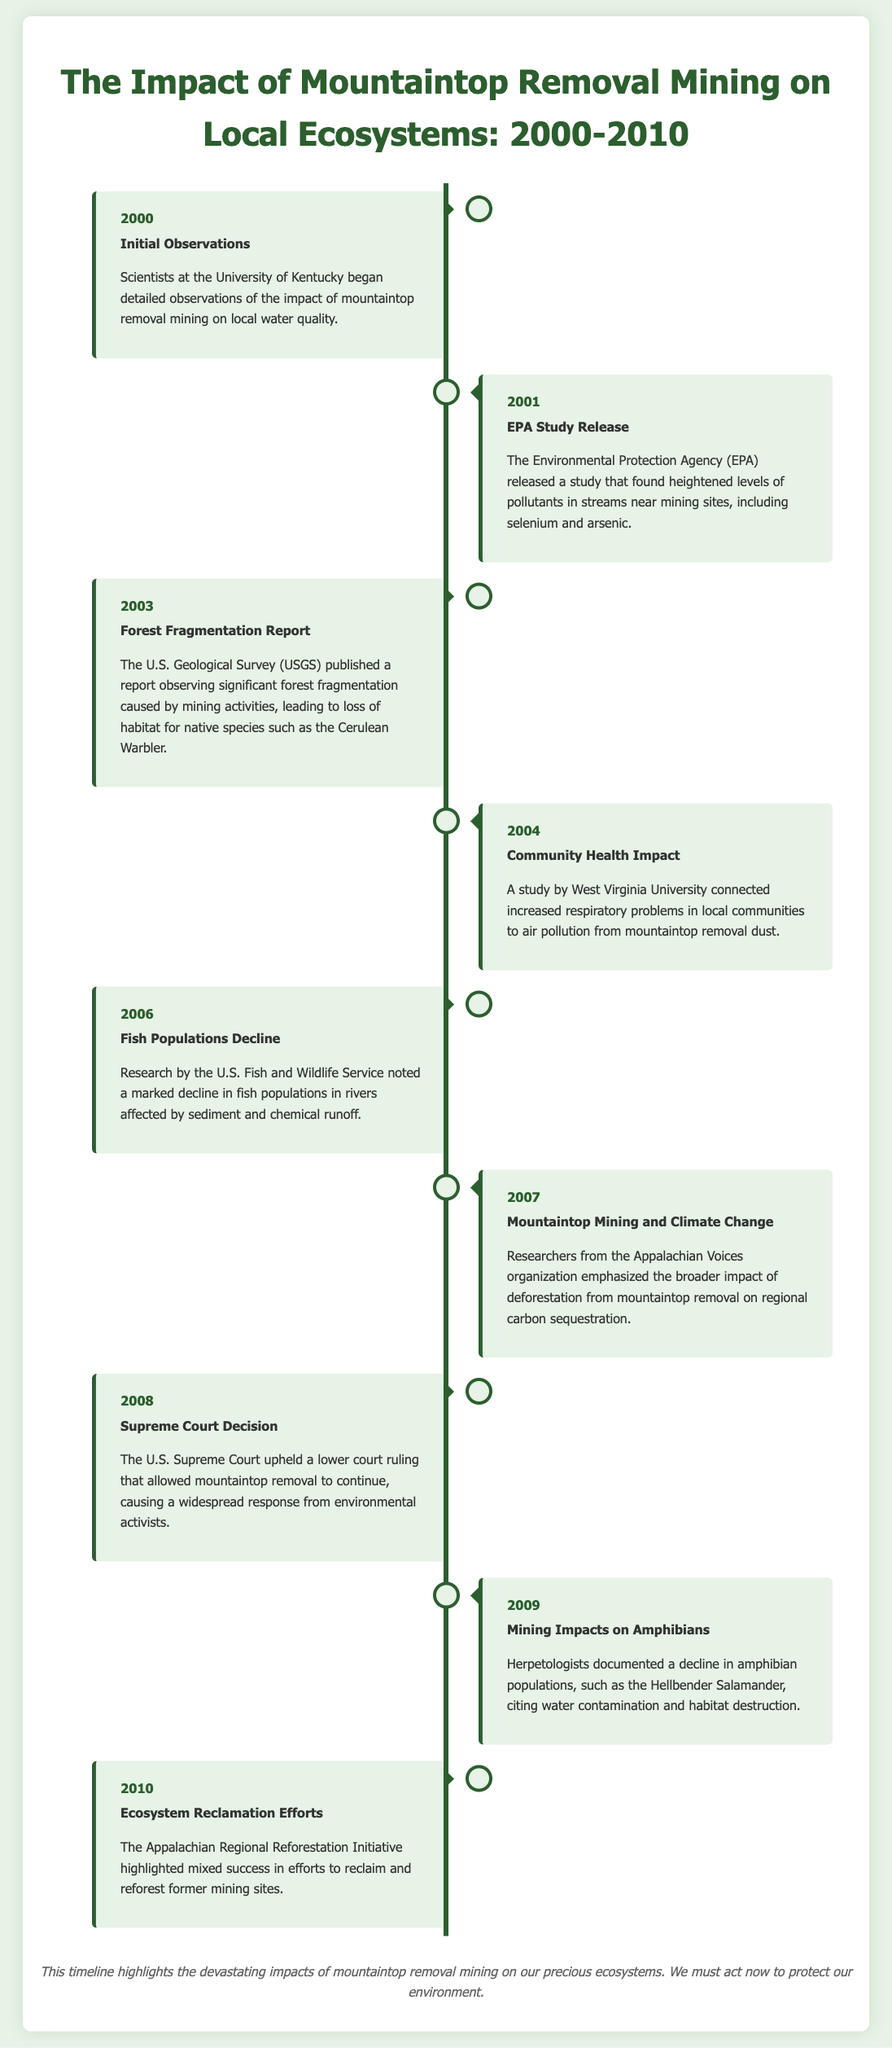What year did scientists at the University of Kentucky begin observing the impact of mountaintop removal mining? The document states that detailed observations began in 2000.
Answer: 2000 What pollutants did the EPA study find heightened levels of near mining sites? The pollutants mentioned in the EPA study are selenium and arsenic.
Answer: Selenium and arsenic Which report observed significant forest fragmentation caused by mining activities? The U.S. Geological Survey published the report on forest fragmentation.
Answer: U.S. Geological Survey What species was noted as losing habitat due to forest fragmentation in 2003? The Cerulean Warbler was specifically mentioned as losing habitat.
Answer: Cerulean Warbler What year did the U.S. Supreme Court uphold a ruling that allowed mountaintop removal to continue? The ruling was upheld in 2008.
Answer: 2008 Which amphibian's population declined due to water contamination and habitat destruction? The Hellbender Salamander was documented for this decline.
Answer: Hellbender Salamander What initiative highlighted mixed success in reforesting former mining sites by 2010? The Appalachian Regional Reforestation Initiative focused on these efforts.
Answer: Appalachian Regional Reforestation Initiative What health issues were connected to mountaintop removal dust in communities? The study linked air pollution from dust to increased respiratory problems.
Answer: Respiratory problems What broader impact did deforestation from mountaintop removal have according to Appalachian Voices in 2007? It affected regional carbon sequestration.
Answer: Regional carbon sequestration 